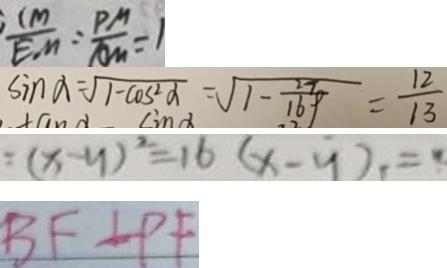Convert formula to latex. <formula><loc_0><loc_0><loc_500><loc_500>\frac { C M } { E M } = \frac { P M } { A M } = 
 \sin \alpha = \sqrt { 1 - \cos ^ { 2 } \alpha } = \sqrt { 1 - \frac { 2 7 } { 1 6 9 } } = \frac { 1 2 } { 1 3 } 
 = ( x - y ) ^ { 2 } = 1 6 ( x - y ) = y 
 B F \bot P F</formula> 